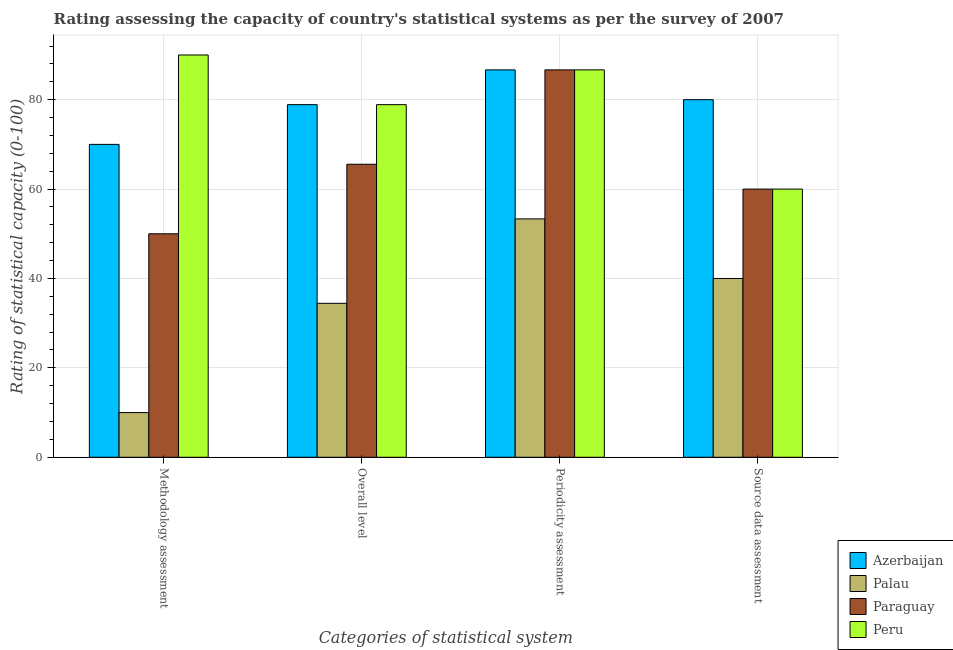How many groups of bars are there?
Offer a very short reply. 4. Are the number of bars on each tick of the X-axis equal?
Offer a terse response. Yes. How many bars are there on the 1st tick from the left?
Your answer should be very brief. 4. How many bars are there on the 4th tick from the right?
Provide a succinct answer. 4. What is the label of the 2nd group of bars from the left?
Keep it short and to the point. Overall level. What is the periodicity assessment rating in Azerbaijan?
Ensure brevity in your answer.  86.67. Across all countries, what is the maximum overall level rating?
Give a very brief answer. 78.89. Across all countries, what is the minimum source data assessment rating?
Your answer should be compact. 40. In which country was the source data assessment rating maximum?
Give a very brief answer. Azerbaijan. In which country was the overall level rating minimum?
Make the answer very short. Palau. What is the total overall level rating in the graph?
Keep it short and to the point. 257.78. What is the difference between the overall level rating in Paraguay and the source data assessment rating in Azerbaijan?
Your answer should be very brief. -14.44. What is the average source data assessment rating per country?
Your answer should be compact. 60. What is the difference between the source data assessment rating and methodology assessment rating in Paraguay?
Provide a short and direct response. 10. What is the ratio of the periodicity assessment rating in Paraguay to that in Palau?
Offer a very short reply. 1.63. Is the difference between the periodicity assessment rating in Palau and Paraguay greater than the difference between the overall level rating in Palau and Paraguay?
Give a very brief answer. No. What is the difference between the highest and the lowest source data assessment rating?
Offer a very short reply. 40. In how many countries, is the periodicity assessment rating greater than the average periodicity assessment rating taken over all countries?
Your response must be concise. 3. What does the 3rd bar from the left in Overall level represents?
Provide a short and direct response. Paraguay. What does the 2nd bar from the right in Source data assessment represents?
Provide a succinct answer. Paraguay. Is it the case that in every country, the sum of the methodology assessment rating and overall level rating is greater than the periodicity assessment rating?
Provide a short and direct response. No. Are all the bars in the graph horizontal?
Keep it short and to the point. No. How many countries are there in the graph?
Your answer should be very brief. 4. What is the difference between two consecutive major ticks on the Y-axis?
Provide a short and direct response. 20. How many legend labels are there?
Your answer should be very brief. 4. How are the legend labels stacked?
Make the answer very short. Vertical. What is the title of the graph?
Offer a very short reply. Rating assessing the capacity of country's statistical systems as per the survey of 2007 . Does "El Salvador" appear as one of the legend labels in the graph?
Provide a succinct answer. No. What is the label or title of the X-axis?
Offer a terse response. Categories of statistical system. What is the label or title of the Y-axis?
Your response must be concise. Rating of statistical capacity (0-100). What is the Rating of statistical capacity (0-100) of Azerbaijan in Overall level?
Give a very brief answer. 78.89. What is the Rating of statistical capacity (0-100) in Palau in Overall level?
Your answer should be very brief. 34.44. What is the Rating of statistical capacity (0-100) of Paraguay in Overall level?
Keep it short and to the point. 65.56. What is the Rating of statistical capacity (0-100) of Peru in Overall level?
Your answer should be compact. 78.89. What is the Rating of statistical capacity (0-100) in Azerbaijan in Periodicity assessment?
Your answer should be very brief. 86.67. What is the Rating of statistical capacity (0-100) in Palau in Periodicity assessment?
Your response must be concise. 53.33. What is the Rating of statistical capacity (0-100) of Paraguay in Periodicity assessment?
Your answer should be very brief. 86.67. What is the Rating of statistical capacity (0-100) in Peru in Periodicity assessment?
Your answer should be very brief. 86.67. Across all Categories of statistical system, what is the maximum Rating of statistical capacity (0-100) in Azerbaijan?
Keep it short and to the point. 86.67. Across all Categories of statistical system, what is the maximum Rating of statistical capacity (0-100) in Palau?
Offer a very short reply. 53.33. Across all Categories of statistical system, what is the maximum Rating of statistical capacity (0-100) of Paraguay?
Make the answer very short. 86.67. What is the total Rating of statistical capacity (0-100) in Azerbaijan in the graph?
Your response must be concise. 315.56. What is the total Rating of statistical capacity (0-100) in Palau in the graph?
Offer a very short reply. 137.78. What is the total Rating of statistical capacity (0-100) of Paraguay in the graph?
Offer a very short reply. 262.22. What is the total Rating of statistical capacity (0-100) of Peru in the graph?
Your answer should be very brief. 315.56. What is the difference between the Rating of statistical capacity (0-100) of Azerbaijan in Methodology assessment and that in Overall level?
Your response must be concise. -8.89. What is the difference between the Rating of statistical capacity (0-100) in Palau in Methodology assessment and that in Overall level?
Make the answer very short. -24.44. What is the difference between the Rating of statistical capacity (0-100) of Paraguay in Methodology assessment and that in Overall level?
Offer a very short reply. -15.56. What is the difference between the Rating of statistical capacity (0-100) in Peru in Methodology assessment and that in Overall level?
Your response must be concise. 11.11. What is the difference between the Rating of statistical capacity (0-100) of Azerbaijan in Methodology assessment and that in Periodicity assessment?
Provide a short and direct response. -16.67. What is the difference between the Rating of statistical capacity (0-100) in Palau in Methodology assessment and that in Periodicity assessment?
Offer a terse response. -43.33. What is the difference between the Rating of statistical capacity (0-100) in Paraguay in Methodology assessment and that in Periodicity assessment?
Keep it short and to the point. -36.67. What is the difference between the Rating of statistical capacity (0-100) of Palau in Methodology assessment and that in Source data assessment?
Offer a very short reply. -30. What is the difference between the Rating of statistical capacity (0-100) in Peru in Methodology assessment and that in Source data assessment?
Keep it short and to the point. 30. What is the difference between the Rating of statistical capacity (0-100) in Azerbaijan in Overall level and that in Periodicity assessment?
Provide a succinct answer. -7.78. What is the difference between the Rating of statistical capacity (0-100) in Palau in Overall level and that in Periodicity assessment?
Your answer should be compact. -18.89. What is the difference between the Rating of statistical capacity (0-100) in Paraguay in Overall level and that in Periodicity assessment?
Your response must be concise. -21.11. What is the difference between the Rating of statistical capacity (0-100) in Peru in Overall level and that in Periodicity assessment?
Your answer should be very brief. -7.78. What is the difference between the Rating of statistical capacity (0-100) in Azerbaijan in Overall level and that in Source data assessment?
Provide a succinct answer. -1.11. What is the difference between the Rating of statistical capacity (0-100) in Palau in Overall level and that in Source data assessment?
Give a very brief answer. -5.56. What is the difference between the Rating of statistical capacity (0-100) of Paraguay in Overall level and that in Source data assessment?
Give a very brief answer. 5.56. What is the difference between the Rating of statistical capacity (0-100) of Peru in Overall level and that in Source data assessment?
Provide a succinct answer. 18.89. What is the difference between the Rating of statistical capacity (0-100) of Azerbaijan in Periodicity assessment and that in Source data assessment?
Your response must be concise. 6.67. What is the difference between the Rating of statistical capacity (0-100) of Palau in Periodicity assessment and that in Source data assessment?
Your response must be concise. 13.33. What is the difference between the Rating of statistical capacity (0-100) of Paraguay in Periodicity assessment and that in Source data assessment?
Your answer should be compact. 26.67. What is the difference between the Rating of statistical capacity (0-100) in Peru in Periodicity assessment and that in Source data assessment?
Keep it short and to the point. 26.67. What is the difference between the Rating of statistical capacity (0-100) in Azerbaijan in Methodology assessment and the Rating of statistical capacity (0-100) in Palau in Overall level?
Your answer should be compact. 35.56. What is the difference between the Rating of statistical capacity (0-100) of Azerbaijan in Methodology assessment and the Rating of statistical capacity (0-100) of Paraguay in Overall level?
Give a very brief answer. 4.44. What is the difference between the Rating of statistical capacity (0-100) of Azerbaijan in Methodology assessment and the Rating of statistical capacity (0-100) of Peru in Overall level?
Your response must be concise. -8.89. What is the difference between the Rating of statistical capacity (0-100) in Palau in Methodology assessment and the Rating of statistical capacity (0-100) in Paraguay in Overall level?
Your answer should be compact. -55.56. What is the difference between the Rating of statistical capacity (0-100) in Palau in Methodology assessment and the Rating of statistical capacity (0-100) in Peru in Overall level?
Keep it short and to the point. -68.89. What is the difference between the Rating of statistical capacity (0-100) in Paraguay in Methodology assessment and the Rating of statistical capacity (0-100) in Peru in Overall level?
Your response must be concise. -28.89. What is the difference between the Rating of statistical capacity (0-100) in Azerbaijan in Methodology assessment and the Rating of statistical capacity (0-100) in Palau in Periodicity assessment?
Your answer should be compact. 16.67. What is the difference between the Rating of statistical capacity (0-100) in Azerbaijan in Methodology assessment and the Rating of statistical capacity (0-100) in Paraguay in Periodicity assessment?
Provide a succinct answer. -16.67. What is the difference between the Rating of statistical capacity (0-100) in Azerbaijan in Methodology assessment and the Rating of statistical capacity (0-100) in Peru in Periodicity assessment?
Give a very brief answer. -16.67. What is the difference between the Rating of statistical capacity (0-100) of Palau in Methodology assessment and the Rating of statistical capacity (0-100) of Paraguay in Periodicity assessment?
Make the answer very short. -76.67. What is the difference between the Rating of statistical capacity (0-100) of Palau in Methodology assessment and the Rating of statistical capacity (0-100) of Peru in Periodicity assessment?
Give a very brief answer. -76.67. What is the difference between the Rating of statistical capacity (0-100) of Paraguay in Methodology assessment and the Rating of statistical capacity (0-100) of Peru in Periodicity assessment?
Make the answer very short. -36.67. What is the difference between the Rating of statistical capacity (0-100) in Azerbaijan in Methodology assessment and the Rating of statistical capacity (0-100) in Palau in Source data assessment?
Offer a terse response. 30. What is the difference between the Rating of statistical capacity (0-100) of Azerbaijan in Methodology assessment and the Rating of statistical capacity (0-100) of Paraguay in Source data assessment?
Give a very brief answer. 10. What is the difference between the Rating of statistical capacity (0-100) in Palau in Methodology assessment and the Rating of statistical capacity (0-100) in Peru in Source data assessment?
Your answer should be compact. -50. What is the difference between the Rating of statistical capacity (0-100) in Azerbaijan in Overall level and the Rating of statistical capacity (0-100) in Palau in Periodicity assessment?
Give a very brief answer. 25.56. What is the difference between the Rating of statistical capacity (0-100) of Azerbaijan in Overall level and the Rating of statistical capacity (0-100) of Paraguay in Periodicity assessment?
Offer a terse response. -7.78. What is the difference between the Rating of statistical capacity (0-100) in Azerbaijan in Overall level and the Rating of statistical capacity (0-100) in Peru in Periodicity assessment?
Your answer should be very brief. -7.78. What is the difference between the Rating of statistical capacity (0-100) of Palau in Overall level and the Rating of statistical capacity (0-100) of Paraguay in Periodicity assessment?
Your answer should be compact. -52.22. What is the difference between the Rating of statistical capacity (0-100) of Palau in Overall level and the Rating of statistical capacity (0-100) of Peru in Periodicity assessment?
Provide a succinct answer. -52.22. What is the difference between the Rating of statistical capacity (0-100) of Paraguay in Overall level and the Rating of statistical capacity (0-100) of Peru in Periodicity assessment?
Offer a terse response. -21.11. What is the difference between the Rating of statistical capacity (0-100) in Azerbaijan in Overall level and the Rating of statistical capacity (0-100) in Palau in Source data assessment?
Your answer should be very brief. 38.89. What is the difference between the Rating of statistical capacity (0-100) of Azerbaijan in Overall level and the Rating of statistical capacity (0-100) of Paraguay in Source data assessment?
Keep it short and to the point. 18.89. What is the difference between the Rating of statistical capacity (0-100) in Azerbaijan in Overall level and the Rating of statistical capacity (0-100) in Peru in Source data assessment?
Provide a short and direct response. 18.89. What is the difference between the Rating of statistical capacity (0-100) of Palau in Overall level and the Rating of statistical capacity (0-100) of Paraguay in Source data assessment?
Keep it short and to the point. -25.56. What is the difference between the Rating of statistical capacity (0-100) in Palau in Overall level and the Rating of statistical capacity (0-100) in Peru in Source data assessment?
Your answer should be compact. -25.56. What is the difference between the Rating of statistical capacity (0-100) in Paraguay in Overall level and the Rating of statistical capacity (0-100) in Peru in Source data assessment?
Offer a terse response. 5.56. What is the difference between the Rating of statistical capacity (0-100) in Azerbaijan in Periodicity assessment and the Rating of statistical capacity (0-100) in Palau in Source data assessment?
Keep it short and to the point. 46.67. What is the difference between the Rating of statistical capacity (0-100) in Azerbaijan in Periodicity assessment and the Rating of statistical capacity (0-100) in Paraguay in Source data assessment?
Ensure brevity in your answer.  26.67. What is the difference between the Rating of statistical capacity (0-100) of Azerbaijan in Periodicity assessment and the Rating of statistical capacity (0-100) of Peru in Source data assessment?
Your answer should be very brief. 26.67. What is the difference between the Rating of statistical capacity (0-100) in Palau in Periodicity assessment and the Rating of statistical capacity (0-100) in Paraguay in Source data assessment?
Give a very brief answer. -6.67. What is the difference between the Rating of statistical capacity (0-100) in Palau in Periodicity assessment and the Rating of statistical capacity (0-100) in Peru in Source data assessment?
Give a very brief answer. -6.67. What is the difference between the Rating of statistical capacity (0-100) in Paraguay in Periodicity assessment and the Rating of statistical capacity (0-100) in Peru in Source data assessment?
Ensure brevity in your answer.  26.67. What is the average Rating of statistical capacity (0-100) of Azerbaijan per Categories of statistical system?
Keep it short and to the point. 78.89. What is the average Rating of statistical capacity (0-100) of Palau per Categories of statistical system?
Your response must be concise. 34.44. What is the average Rating of statistical capacity (0-100) of Paraguay per Categories of statistical system?
Provide a short and direct response. 65.56. What is the average Rating of statistical capacity (0-100) in Peru per Categories of statistical system?
Ensure brevity in your answer.  78.89. What is the difference between the Rating of statistical capacity (0-100) of Azerbaijan and Rating of statistical capacity (0-100) of Palau in Methodology assessment?
Keep it short and to the point. 60. What is the difference between the Rating of statistical capacity (0-100) of Azerbaijan and Rating of statistical capacity (0-100) of Paraguay in Methodology assessment?
Keep it short and to the point. 20. What is the difference between the Rating of statistical capacity (0-100) in Palau and Rating of statistical capacity (0-100) in Peru in Methodology assessment?
Provide a short and direct response. -80. What is the difference between the Rating of statistical capacity (0-100) of Paraguay and Rating of statistical capacity (0-100) of Peru in Methodology assessment?
Your answer should be very brief. -40. What is the difference between the Rating of statistical capacity (0-100) of Azerbaijan and Rating of statistical capacity (0-100) of Palau in Overall level?
Your response must be concise. 44.44. What is the difference between the Rating of statistical capacity (0-100) of Azerbaijan and Rating of statistical capacity (0-100) of Paraguay in Overall level?
Keep it short and to the point. 13.33. What is the difference between the Rating of statistical capacity (0-100) in Palau and Rating of statistical capacity (0-100) in Paraguay in Overall level?
Your answer should be very brief. -31.11. What is the difference between the Rating of statistical capacity (0-100) of Palau and Rating of statistical capacity (0-100) of Peru in Overall level?
Offer a terse response. -44.44. What is the difference between the Rating of statistical capacity (0-100) of Paraguay and Rating of statistical capacity (0-100) of Peru in Overall level?
Your response must be concise. -13.33. What is the difference between the Rating of statistical capacity (0-100) in Azerbaijan and Rating of statistical capacity (0-100) in Palau in Periodicity assessment?
Your response must be concise. 33.33. What is the difference between the Rating of statistical capacity (0-100) of Azerbaijan and Rating of statistical capacity (0-100) of Paraguay in Periodicity assessment?
Provide a short and direct response. 0. What is the difference between the Rating of statistical capacity (0-100) of Palau and Rating of statistical capacity (0-100) of Paraguay in Periodicity assessment?
Provide a short and direct response. -33.33. What is the difference between the Rating of statistical capacity (0-100) in Palau and Rating of statistical capacity (0-100) in Peru in Periodicity assessment?
Give a very brief answer. -33.33. What is the difference between the Rating of statistical capacity (0-100) of Paraguay and Rating of statistical capacity (0-100) of Peru in Periodicity assessment?
Your answer should be compact. 0. What is the difference between the Rating of statistical capacity (0-100) of Azerbaijan and Rating of statistical capacity (0-100) of Paraguay in Source data assessment?
Give a very brief answer. 20. What is the difference between the Rating of statistical capacity (0-100) in Azerbaijan and Rating of statistical capacity (0-100) in Peru in Source data assessment?
Offer a terse response. 20. What is the difference between the Rating of statistical capacity (0-100) of Palau and Rating of statistical capacity (0-100) of Peru in Source data assessment?
Offer a very short reply. -20. What is the difference between the Rating of statistical capacity (0-100) in Paraguay and Rating of statistical capacity (0-100) in Peru in Source data assessment?
Provide a short and direct response. 0. What is the ratio of the Rating of statistical capacity (0-100) of Azerbaijan in Methodology assessment to that in Overall level?
Give a very brief answer. 0.89. What is the ratio of the Rating of statistical capacity (0-100) in Palau in Methodology assessment to that in Overall level?
Offer a very short reply. 0.29. What is the ratio of the Rating of statistical capacity (0-100) of Paraguay in Methodology assessment to that in Overall level?
Your answer should be compact. 0.76. What is the ratio of the Rating of statistical capacity (0-100) in Peru in Methodology assessment to that in Overall level?
Give a very brief answer. 1.14. What is the ratio of the Rating of statistical capacity (0-100) of Azerbaijan in Methodology assessment to that in Periodicity assessment?
Your answer should be very brief. 0.81. What is the ratio of the Rating of statistical capacity (0-100) in Palau in Methodology assessment to that in Periodicity assessment?
Offer a terse response. 0.19. What is the ratio of the Rating of statistical capacity (0-100) in Paraguay in Methodology assessment to that in Periodicity assessment?
Give a very brief answer. 0.58. What is the ratio of the Rating of statistical capacity (0-100) in Azerbaijan in Methodology assessment to that in Source data assessment?
Give a very brief answer. 0.88. What is the ratio of the Rating of statistical capacity (0-100) in Palau in Methodology assessment to that in Source data assessment?
Ensure brevity in your answer.  0.25. What is the ratio of the Rating of statistical capacity (0-100) of Azerbaijan in Overall level to that in Periodicity assessment?
Offer a terse response. 0.91. What is the ratio of the Rating of statistical capacity (0-100) in Palau in Overall level to that in Periodicity assessment?
Provide a succinct answer. 0.65. What is the ratio of the Rating of statistical capacity (0-100) in Paraguay in Overall level to that in Periodicity assessment?
Offer a very short reply. 0.76. What is the ratio of the Rating of statistical capacity (0-100) of Peru in Overall level to that in Periodicity assessment?
Offer a terse response. 0.91. What is the ratio of the Rating of statistical capacity (0-100) of Azerbaijan in Overall level to that in Source data assessment?
Offer a very short reply. 0.99. What is the ratio of the Rating of statistical capacity (0-100) of Palau in Overall level to that in Source data assessment?
Ensure brevity in your answer.  0.86. What is the ratio of the Rating of statistical capacity (0-100) in Paraguay in Overall level to that in Source data assessment?
Provide a succinct answer. 1.09. What is the ratio of the Rating of statistical capacity (0-100) in Peru in Overall level to that in Source data assessment?
Ensure brevity in your answer.  1.31. What is the ratio of the Rating of statistical capacity (0-100) of Paraguay in Periodicity assessment to that in Source data assessment?
Make the answer very short. 1.44. What is the ratio of the Rating of statistical capacity (0-100) of Peru in Periodicity assessment to that in Source data assessment?
Your response must be concise. 1.44. What is the difference between the highest and the second highest Rating of statistical capacity (0-100) of Palau?
Your response must be concise. 13.33. What is the difference between the highest and the second highest Rating of statistical capacity (0-100) in Paraguay?
Your answer should be compact. 21.11. What is the difference between the highest and the lowest Rating of statistical capacity (0-100) in Azerbaijan?
Your answer should be compact. 16.67. What is the difference between the highest and the lowest Rating of statistical capacity (0-100) in Palau?
Offer a very short reply. 43.33. What is the difference between the highest and the lowest Rating of statistical capacity (0-100) in Paraguay?
Make the answer very short. 36.67. What is the difference between the highest and the lowest Rating of statistical capacity (0-100) in Peru?
Make the answer very short. 30. 